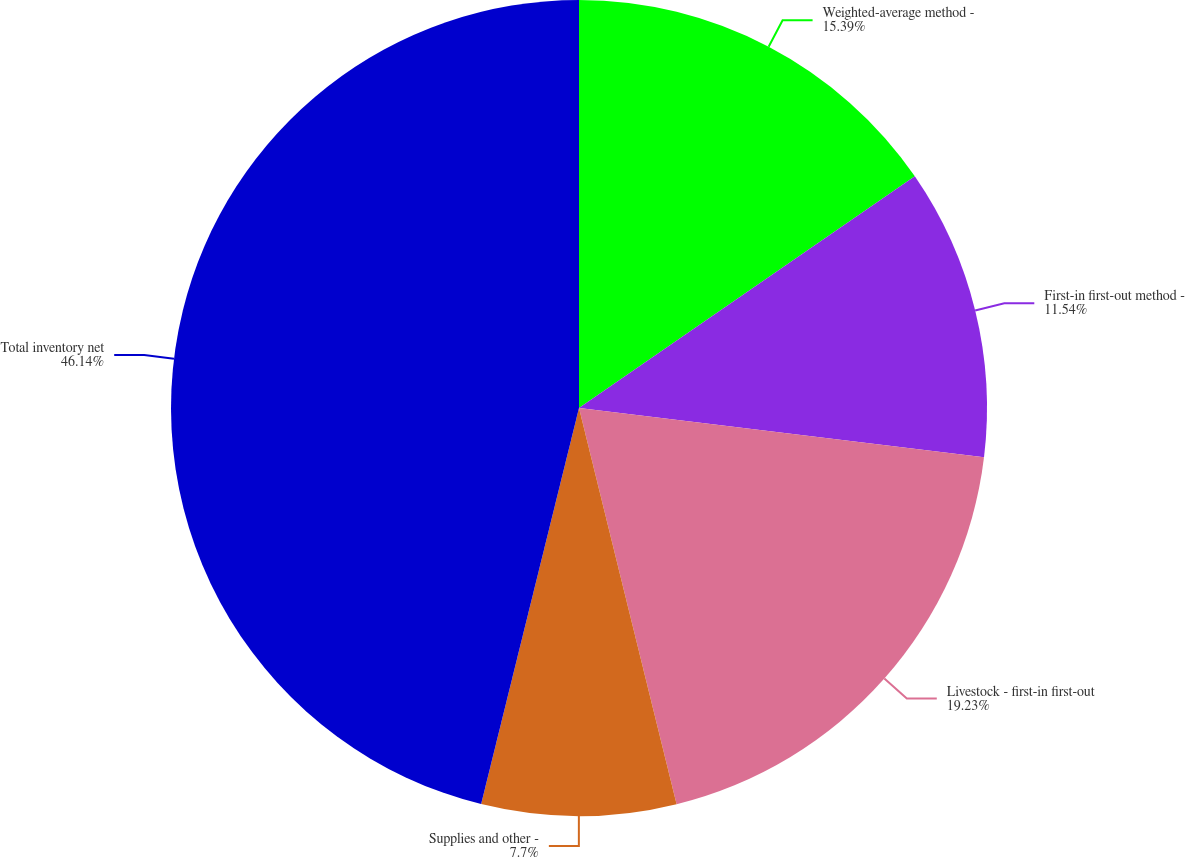<chart> <loc_0><loc_0><loc_500><loc_500><pie_chart><fcel>Weighted-average method -<fcel>First-in first-out method -<fcel>Livestock - first-in first-out<fcel>Supplies and other -<fcel>Total inventory net<nl><fcel>15.39%<fcel>11.54%<fcel>19.23%<fcel>7.7%<fcel>46.15%<nl></chart> 